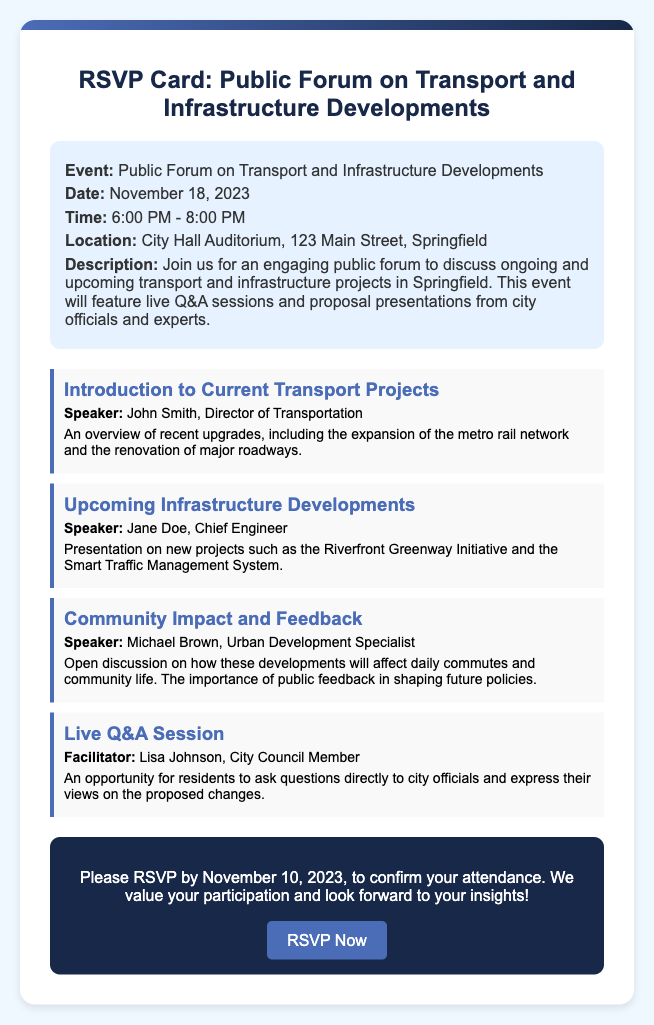What is the event name? The event name is clearly stated at the top of the document, which is "Public Forum on Transport and Infrastructure Developments."
Answer: Public Forum on Transport and Infrastructure Developments What is the date of the event? The date of the event is provided in the event details section.
Answer: November 18, 2023 What is the location of the event? The location is specified in the event details section, giving the address where the forum will take place.
Answer: City Hall Auditorium, 123 Main Street, Springfield Who is the speaker for the "Upcoming Infrastructure Developments"? The speaker for this segment is mentioned directly under the title of the segment.
Answer: Jane Doe What time does the event start? The starting time is indicated in the event details along with the end time.
Answer: 6:00 PM What is the RSVP deadline? The RSVP deadline is clearly provided in the call-to-action section of the document.
Answer: November 10, 2023 What is the focus of the "Community Impact and Feedback" segment? This segment's focus is summarized in the description given under the segment title, indicating what it will discuss.
Answer: Daily commutes and community life Who is facilitating the live Q&A session? The facilitator's name is stated under the live Q&A segment heading.
Answer: Lisa Johnson What is the main purpose of the public forum? The main purpose is outlined in the description section, specifying the event's intentions.
Answer: Discuss ongoing and upcoming transport and infrastructure projects 